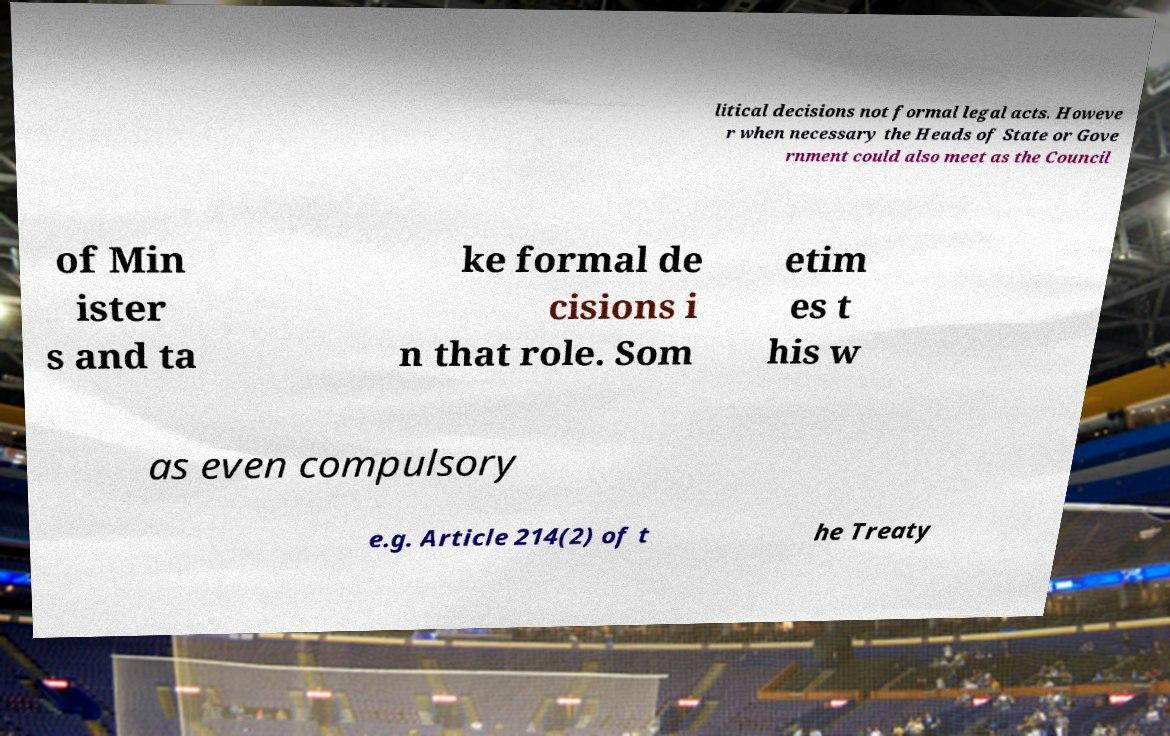Can you accurately transcribe the text from the provided image for me? litical decisions not formal legal acts. Howeve r when necessary the Heads of State or Gove rnment could also meet as the Council of Min ister s and ta ke formal de cisions i n that role. Som etim es t his w as even compulsory e.g. Article 214(2) of t he Treaty 